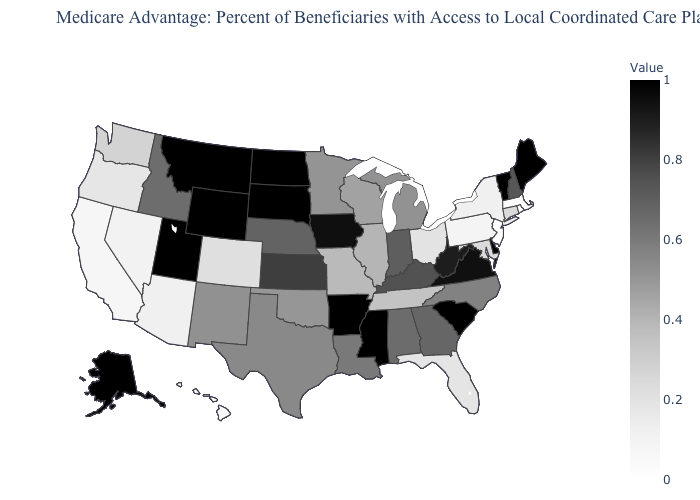Which states hav the highest value in the West?
Give a very brief answer. Alaska, Montana, Utah, Wyoming. Among the states that border West Virginia , which have the lowest value?
Short answer required. Pennsylvania. Does Connecticut have the highest value in the USA?
Give a very brief answer. No. Which states have the highest value in the USA?
Give a very brief answer. Alaska, Arkansas, Delaware, Maine, Mississippi, Montana, North Dakota, South Carolina, South Dakota, Utah, Vermont, Wyoming. Does the map have missing data?
Be succinct. No. 